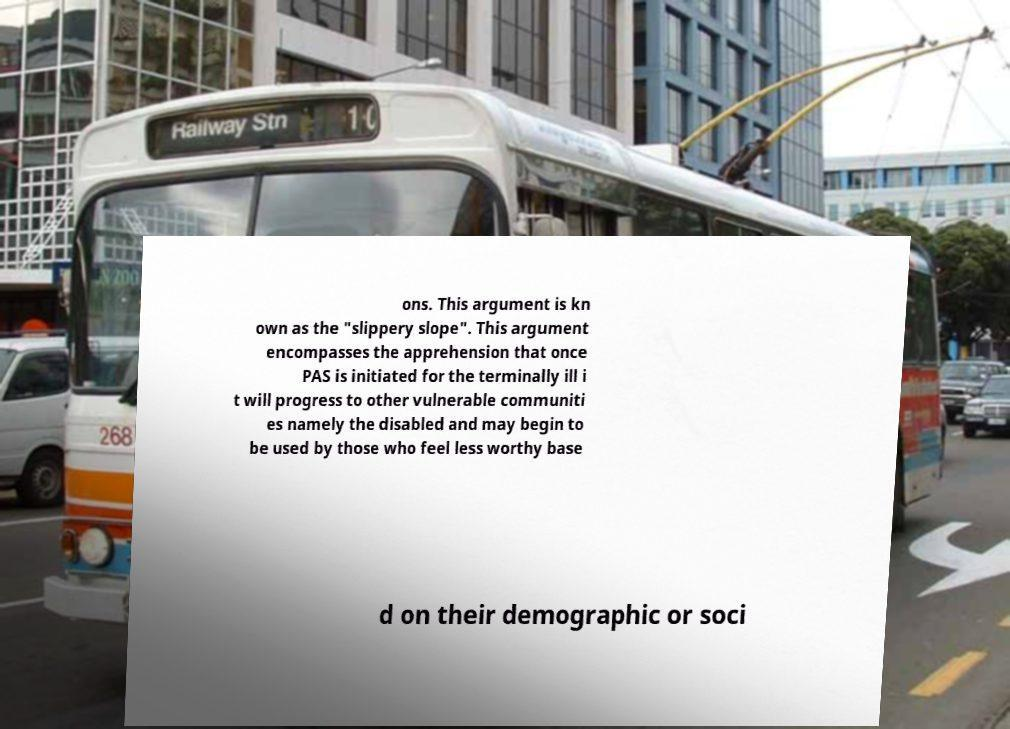Could you extract and type out the text from this image? ons. This argument is kn own as the "slippery slope". This argument encompasses the apprehension that once PAS is initiated for the terminally ill i t will progress to other vulnerable communiti es namely the disabled and may begin to be used by those who feel less worthy base d on their demographic or soci 